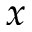<formula> <loc_0><loc_0><loc_500><loc_500>x</formula> 